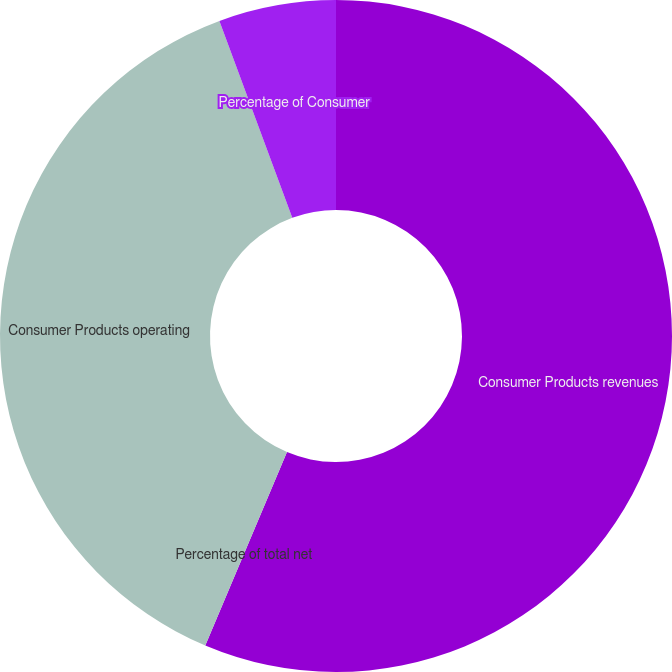<chart> <loc_0><loc_0><loc_500><loc_500><pie_chart><fcel>Consumer Products revenues<fcel>Percentage of total net<fcel>Consumer Products operating<fcel>Percentage of Consumer<nl><fcel>56.36%<fcel>0.0%<fcel>38.0%<fcel>5.64%<nl></chart> 